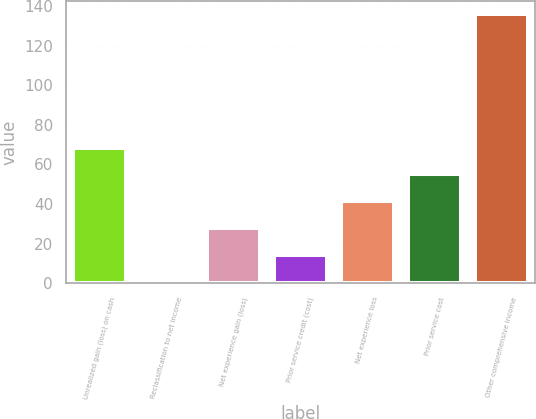Convert chart to OTSL. <chart><loc_0><loc_0><loc_500><loc_500><bar_chart><fcel>Unrealized gain (loss) on cash<fcel>Reclassification to net income<fcel>Net experience gain (loss)<fcel>Prior service credit (cost)<fcel>Net experience loss<fcel>Prior service cost<fcel>Other comprehensive income<nl><fcel>68.5<fcel>1<fcel>28<fcel>14.5<fcel>41.5<fcel>55<fcel>136<nl></chart> 